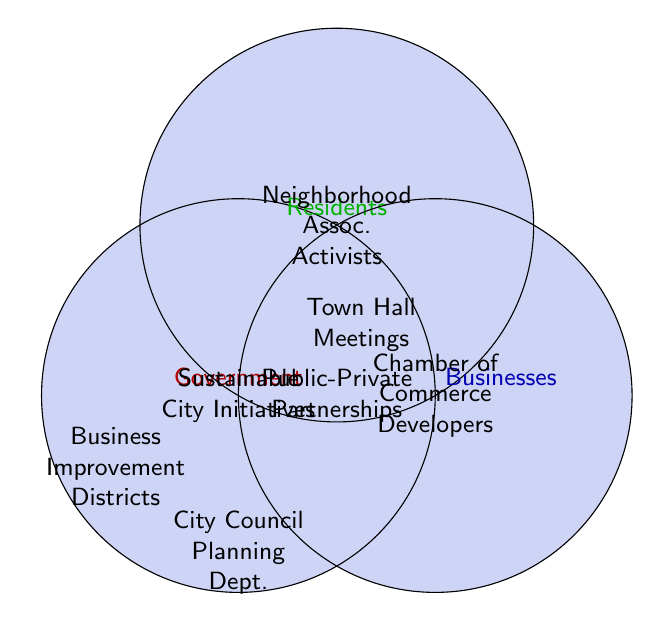What are two examples of stakeholders in the "Government" category? The "Government" category includes "City Council" and "Urban Planning Department" as stakeholders.
Answer: City Council, Urban Planning Department Which category does "Chamber of Commerce" belong to? By examining the placement in the Venn diagram, "Chamber of Commerce" is within the "Businesses" circle.
Answer: Businesses What initiative involves all three stakeholders: government, businesses, and residents? The figure shows that "Sustainable City Initiatives" is located in the intersection where all three circles overlap, indicating it involves all three stakeholders.
Answer: Sustainable City Initiatives Where would we find "Town Hall Meetings" in the diagram? "Town Hall Meetings" is located at the intersection of the "Government" and "Residents" circles.
Answer: Government & Residents Do "Public-Private Partnerships" involve residents directly? According to the Venn diagram, "Public-Private Partnerships" is in the intersection of "Government" and "Businesses," not involving "Residents" directly.
Answer: No What color represents initiatives involving residents? The color corresponding to residents in the Venn diagram is green.
Answer: Green How do "Business Improvement Districts" relate to the stakeholder groups? "Business Improvement Districts" are at the intersection of the "Businesses" and "Residents" circles, meaning they involve both businesses and residents.
Answer: Businesses & Residents Which stakeholder category is involved in all intersections (including with other categories)? The "Government" category intersects with "Businesses" (Public-Private Partnerships), "Residents" (Town Hall Meetings), and both (Sustainable City Initiatives).
Answer: Government Is "Neighborhood Associations" part of any government initiatives based on the figure? "Neighborhood Associations" is purely in the residents' category without intersecting the government circle, indicating no direct involvement in government initiatives.
Answer: No 